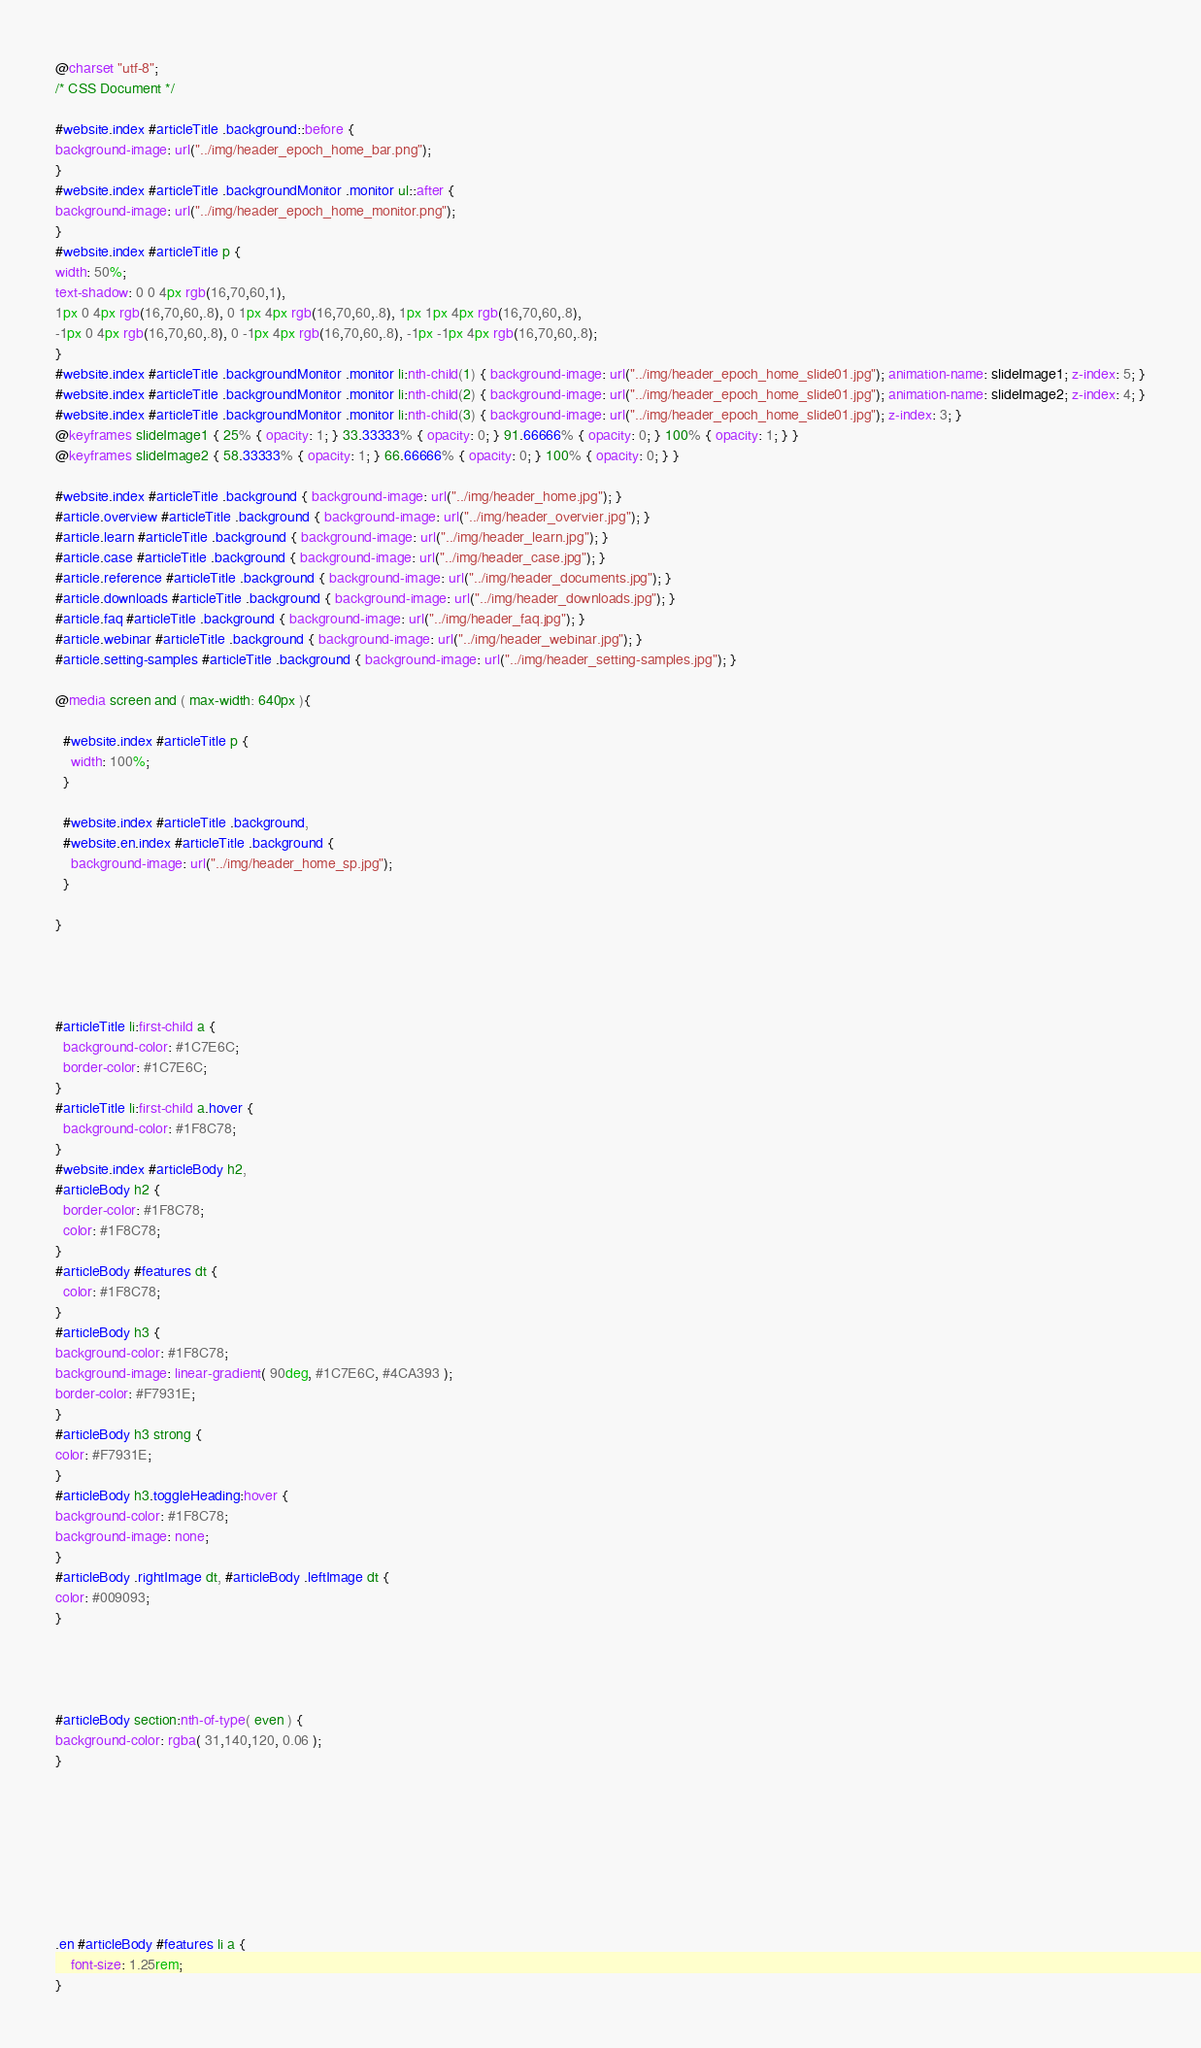Convert code to text. <code><loc_0><loc_0><loc_500><loc_500><_CSS_>@charset "utf-8";
/* CSS Document */

#website.index #articleTitle .background::before {
background-image: url("../img/header_epoch_home_bar.png");
}
#website.index #articleTitle .backgroundMonitor .monitor ul::after {
background-image: url("../img/header_epoch_home_monitor.png");
}
#website.index #articleTitle p {
width: 50%;
text-shadow: 0 0 4px rgb(16,70,60,1),
1px 0 4px rgb(16,70,60,.8), 0 1px 4px rgb(16,70,60,.8), 1px 1px 4px rgb(16,70,60,.8),
-1px 0 4px rgb(16,70,60,.8), 0 -1px 4px rgb(16,70,60,.8), -1px -1px 4px rgb(16,70,60,.8);
}
#website.index #articleTitle .backgroundMonitor .monitor li:nth-child(1) { background-image: url("../img/header_epoch_home_slide01.jpg"); animation-name: slideImage1; z-index: 5; }
#website.index #articleTitle .backgroundMonitor .monitor li:nth-child(2) { background-image: url("../img/header_epoch_home_slide01.jpg"); animation-name: slideImage2; z-index: 4; }
#website.index #articleTitle .backgroundMonitor .monitor li:nth-child(3) { background-image: url("../img/header_epoch_home_slide01.jpg"); z-index: 3; }
@keyframes slideImage1 { 25% { opacity: 1; } 33.33333% { opacity: 0; } 91.66666% { opacity: 0; } 100% { opacity: 1; } }
@keyframes slideImage2 { 58.33333% { opacity: 1; } 66.66666% { opacity: 0; } 100% { opacity: 0; } }

#website.index #articleTitle .background { background-image: url("../img/header_home.jpg"); }
#article.overview #articleTitle .background { background-image: url("../img/header_overvier.jpg"); }
#article.learn #articleTitle .background { background-image: url("../img/header_learn.jpg"); }
#article.case #articleTitle .background { background-image: url("../img/header_case.jpg"); }
#article.reference #articleTitle .background { background-image: url("../img/header_documents.jpg"); }
#article.downloads #articleTitle .background { background-image: url("../img/header_downloads.jpg"); }
#article.faq #articleTitle .background { background-image: url("../img/header_faq.jpg"); }
#article.webinar #articleTitle .background { background-image: url("../img/header_webinar.jpg"); }
#article.setting-samples #articleTitle .background { background-image: url("../img/header_setting-samples.jpg"); }

@media screen and ( max-width: 640px ){
  
  #website.index #articleTitle p {
    width: 100%;
  }

  #website.index #articleTitle .background,
  #website.en.index #articleTitle .background {
    background-image: url("../img/header_home_sp.jpg");
  }
  
}




#articleTitle li:first-child a {
  background-color: #1C7E6C;
  border-color: #1C7E6C;
}
#articleTitle li:first-child a.hover {
  background-color: #1F8C78;
}
#website.index #articleBody h2,
#articleBody h2 {
  border-color: #1F8C78;
  color: #1F8C78;
}
#articleBody #features dt {
  color: #1F8C78;
}
#articleBody h3 {
background-color: #1F8C78;
background-image: linear-gradient( 90deg, #1C7E6C, #4CA393 );
border-color: #F7931E;
}
#articleBody h3 strong {
color: #F7931E;
}
#articleBody h3.toggleHeading:hover {
background-color: #1F8C78;
background-image: none;
}
#articleBody .rightImage dt, #articleBody .leftImage dt {
color: #009093;
}




#articleBody section:nth-of-type( even ) {
background-color: rgba( 31,140,120, 0.06 );
}








.en #articleBody #features li a {
    font-size: 1.25rem;
}</code> 